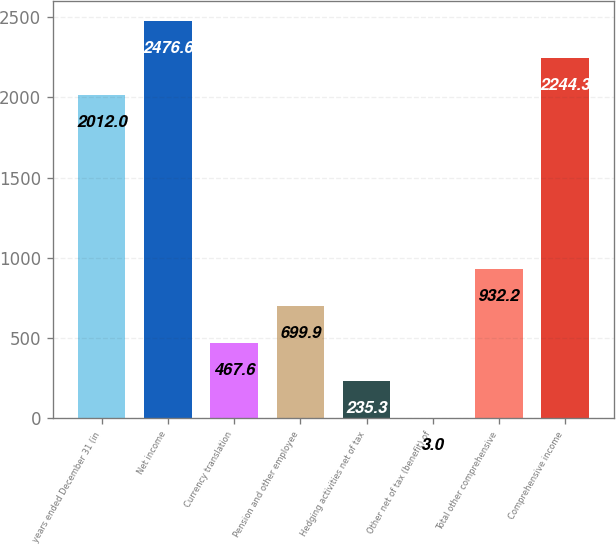<chart> <loc_0><loc_0><loc_500><loc_500><bar_chart><fcel>years ended December 31 (in<fcel>Net income<fcel>Currency translation<fcel>Pension and other employee<fcel>Hedging activities net of tax<fcel>Other net of tax (benefit) of<fcel>Total other comprehensive<fcel>Comprehensive income<nl><fcel>2012<fcel>2476.6<fcel>467.6<fcel>699.9<fcel>235.3<fcel>3<fcel>932.2<fcel>2244.3<nl></chart> 